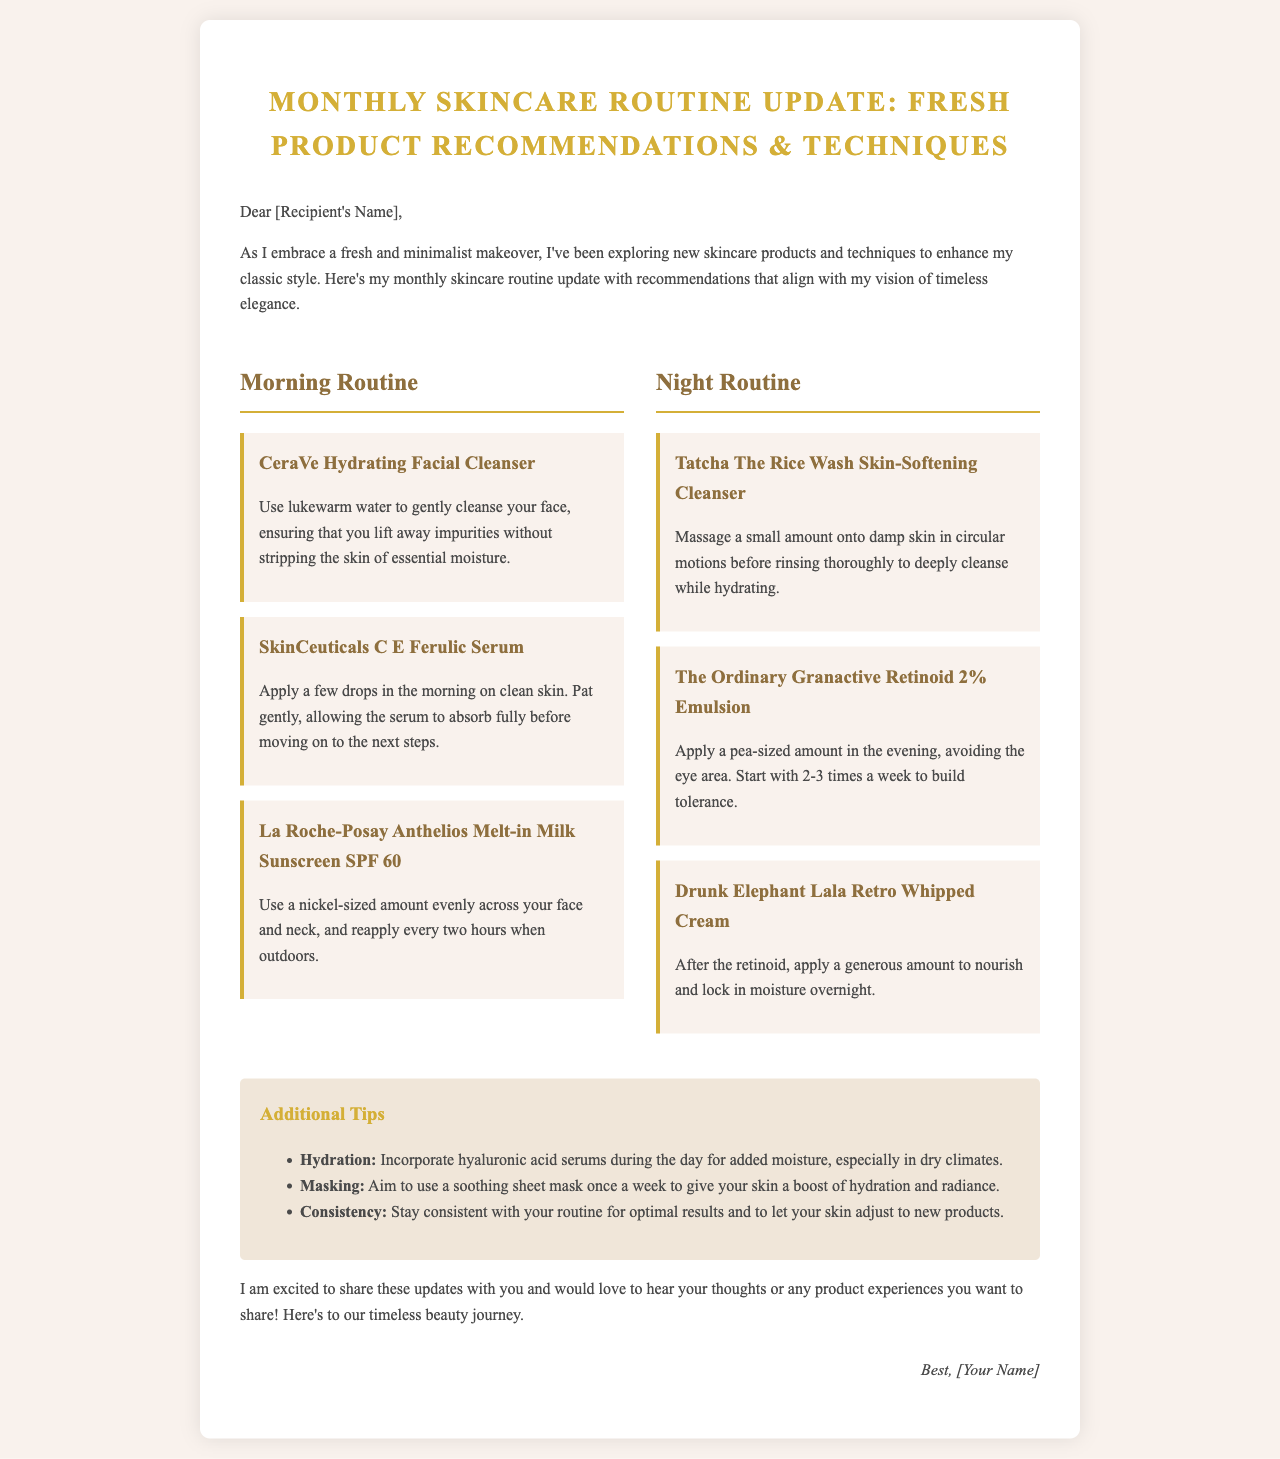What is the title of the document? The title is prominently displayed at the top of the document, indicating the main topic.
Answer: Monthly Skincare Routine Update: Fresh Product Recommendations & Techniques What product is recommended for the morning routine? The document lists specific products for each routine, indicating which are meant for morning or night.
Answer: CeraVe Hydrating Facial Cleanser What is the SPF of the sunscreen mentioned? The document specifies the SPF rating of the recommended sunscreen in the morning routine.
Answer: SPF 60 How often should the retinoid be applied initially? The document provides guidance on how to start using the retinoid product, indicating frequency for beginners.
Answer: 2-3 times a week What type of mask is suggested for weekly use? The additional tips section suggests a type of product to enhance skincare during the week.
Answer: Soothing sheet mask What application technique is advised for the SkinCeuticals serum? The document describes how to apply the serum effectively within the morning routine.
Answer: Pat gently What is the main focus of the skincare update? The introduction of the document outlines the overall approach and aesthetic of the skincare routine.
Answer: Fresh and minimalist makeover What is the purpose of the tips section? The tips provide supplementary advice to support the primary skincare routine mentioned in the document.
Answer: Additional skincare guidance 